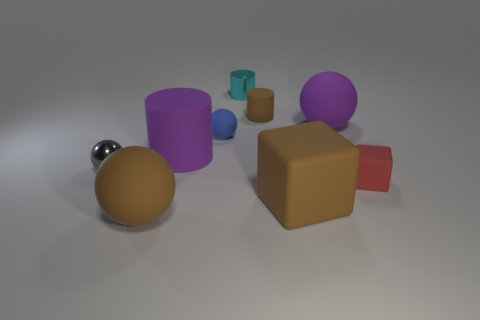There is a gray thing that is the same size as the metallic cylinder; what is its material? metal 